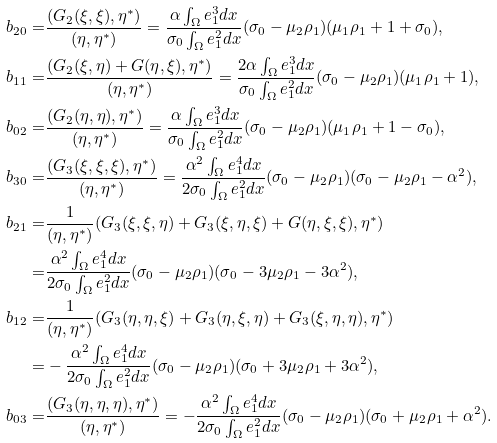Convert formula to latex. <formula><loc_0><loc_0><loc_500><loc_500>b _ { 2 0 } = & \frac { ( G _ { 2 } ( \xi , \xi ) , \eta ^ { * } ) } { ( \eta , \eta ^ { * } ) } = \frac { \alpha \int _ { \Omega } e ^ { 3 } _ { 1 } d x } { \sigma _ { 0 } \int _ { \Omega } e ^ { 2 } _ { 1 } d x } ( \sigma _ { 0 } - \mu _ { 2 } \rho _ { 1 } ) ( \mu _ { 1 } \rho _ { 1 } + 1 + \sigma _ { 0 } ) , \\ b _ { 1 1 } = & \frac { ( G _ { 2 } ( \xi , \eta ) + G ( \eta , \xi ) , \eta ^ { * } ) } { ( \eta , \eta ^ { * } ) } = \frac { 2 \alpha \int _ { \Omega } e ^ { 3 } _ { 1 } d x } { \sigma _ { 0 } \int _ { \Omega } e ^ { 2 } _ { 1 } d x } ( \sigma _ { 0 } - \mu _ { 2 } \rho _ { 1 } ) ( \mu _ { 1 } \rho _ { 1 } + 1 ) , \\ b _ { 0 2 } = & \frac { ( G _ { 2 } ( \eta , \eta ) , \eta ^ { * } ) } { ( \eta , \eta ^ { * } ) } = \frac { \alpha \int _ { \Omega } e ^ { 3 } _ { 1 } d x } { \sigma _ { 0 } \int _ { \Omega } e ^ { 2 } _ { 1 } d x } ( \sigma _ { 0 } - \mu _ { 2 } \rho _ { 1 } ) ( \mu _ { 1 } \rho _ { 1 } + 1 - \sigma _ { 0 } ) , \\ b _ { 3 0 } = & \frac { ( G _ { 3 } ( \xi , \xi , \xi ) , \eta ^ { * } ) } { ( \eta , \eta ^ { * } ) } = \frac { \alpha ^ { 2 } \int _ { \Omega } e ^ { 4 } _ { 1 } d x } { 2 \sigma _ { 0 } \int _ { \Omega } e ^ { 2 } _ { 1 } d x } ( \sigma _ { 0 } - \mu _ { 2 } \rho _ { 1 } ) ( \sigma _ { 0 } - \mu _ { 2 } \rho _ { 1 } - \alpha ^ { 2 } ) , \\ b _ { 2 1 } = & \frac { 1 } { ( \eta , \eta ^ { * } ) } ( G _ { 3 } ( \xi , \xi , \eta ) + G _ { 3 } ( \xi , \eta , \xi ) + G ( \eta , \xi , \xi ) , \eta ^ { * } ) \\ = & \frac { \alpha ^ { 2 } \int _ { \Omega } e ^ { 4 } _ { 1 } d x } { 2 \sigma _ { 0 } \int _ { \Omega } e ^ { 2 } _ { 1 } d x } ( \sigma _ { 0 } - \mu _ { 2 } \rho _ { 1 } ) ( \sigma _ { 0 } - 3 \mu _ { 2 } \rho _ { 1 } - 3 \alpha ^ { 2 } ) , \\ b _ { 1 2 } = & \frac { 1 } { ( \eta , \eta ^ { * } ) } ( G _ { 3 } ( \eta , \eta , \xi ) + G _ { 3 } ( \eta , \xi , \eta ) + G _ { 3 } ( \xi , \eta , \eta ) , \eta ^ { * } ) \\ = & - \frac { \alpha ^ { 2 } \int _ { \Omega } e ^ { 4 } _ { 1 } d x } { 2 \sigma _ { 0 } \int _ { \Omega } e ^ { 2 } _ { 1 } d x } ( \sigma _ { 0 } - \mu _ { 2 } \rho _ { 1 } ) ( \sigma _ { 0 } + 3 \mu _ { 2 } \rho _ { 1 } + 3 \alpha ^ { 2 } ) , \\ b _ { 0 3 } = & \frac { ( G _ { 3 } ( \eta , \eta , \eta ) , \eta ^ { * } ) } { ( \eta , \eta ^ { * } ) } = - \frac { \alpha ^ { 2 } \int _ { \Omega } e ^ { 4 } _ { 1 } d x } { 2 \sigma _ { 0 } \int _ { \Omega } e ^ { 2 } _ { 1 } d x } ( \sigma _ { 0 } - \mu _ { 2 } \rho _ { 1 } ) ( \sigma _ { 0 } + \mu _ { 2 } \rho _ { 1 } + \alpha ^ { 2 } ) .</formula> 